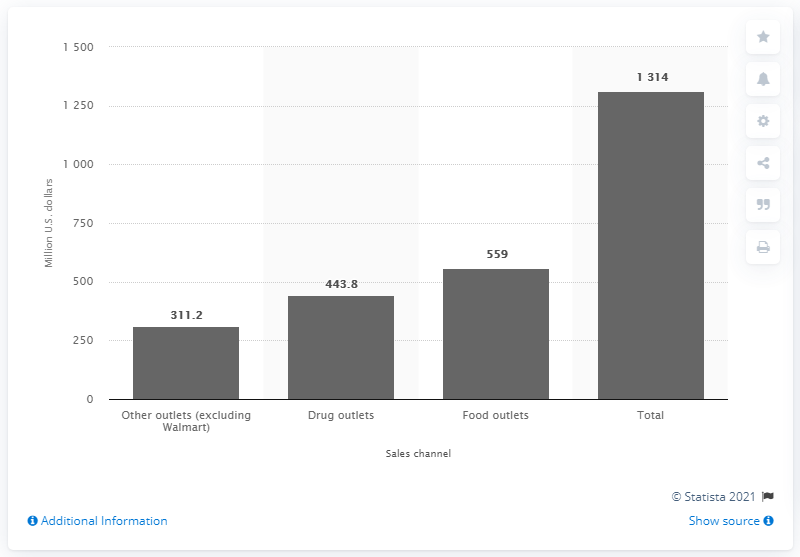What additional information can be inferred about consumer behavior from this sales data? The chart suggests that consumers prefer purchasing deodorant from a variety of outlets, with food outlets being particularly popular, perhaps due to the convenience of buying personal care items along with groceries. The data shows that drug outlets also play a significant role, which could be attributed to consumers' trust in these outlets for health and personal care products. Meanwhile, 'Other outlets', even when excluding a major retailer like Walmart, still account for a considerable share, indicating a diverse marketplace with multiple preferred shopping destinations for deodorants. 